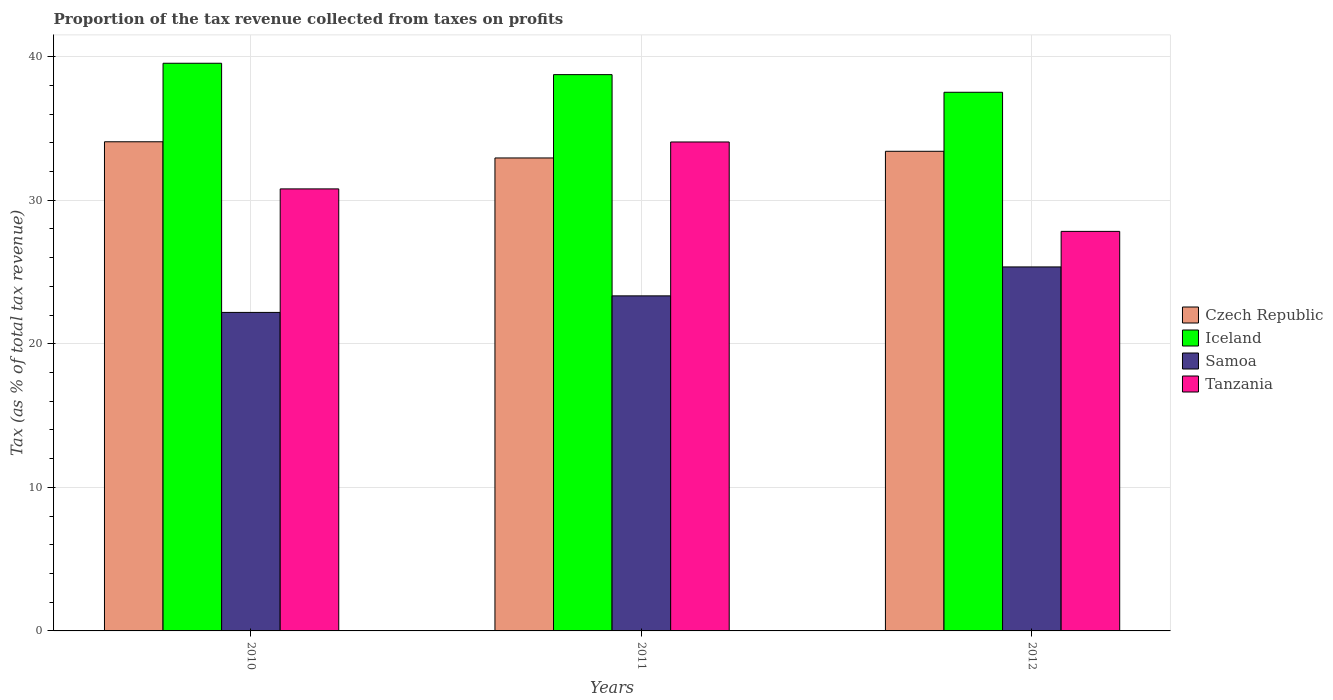How many different coloured bars are there?
Your response must be concise. 4. How many groups of bars are there?
Provide a short and direct response. 3. What is the proportion of the tax revenue collected in Czech Republic in 2011?
Provide a short and direct response. 32.94. Across all years, what is the maximum proportion of the tax revenue collected in Iceland?
Your answer should be very brief. 39.53. Across all years, what is the minimum proportion of the tax revenue collected in Czech Republic?
Ensure brevity in your answer.  32.94. In which year was the proportion of the tax revenue collected in Samoa maximum?
Give a very brief answer. 2012. In which year was the proportion of the tax revenue collected in Czech Republic minimum?
Your answer should be compact. 2011. What is the total proportion of the tax revenue collected in Tanzania in the graph?
Provide a succinct answer. 92.66. What is the difference between the proportion of the tax revenue collected in Samoa in 2010 and that in 2011?
Provide a succinct answer. -1.15. What is the difference between the proportion of the tax revenue collected in Iceland in 2010 and the proportion of the tax revenue collected in Tanzania in 2012?
Provide a short and direct response. 11.71. What is the average proportion of the tax revenue collected in Tanzania per year?
Keep it short and to the point. 30.89. In the year 2011, what is the difference between the proportion of the tax revenue collected in Tanzania and proportion of the tax revenue collected in Iceland?
Ensure brevity in your answer.  -4.69. In how many years, is the proportion of the tax revenue collected in Tanzania greater than 16 %?
Your answer should be very brief. 3. What is the ratio of the proportion of the tax revenue collected in Czech Republic in 2010 to that in 2012?
Keep it short and to the point. 1.02. Is the proportion of the tax revenue collected in Samoa in 2010 less than that in 2011?
Make the answer very short. Yes. What is the difference between the highest and the second highest proportion of the tax revenue collected in Czech Republic?
Your response must be concise. 0.66. What is the difference between the highest and the lowest proportion of the tax revenue collected in Czech Republic?
Your response must be concise. 1.13. What does the 3rd bar from the left in 2012 represents?
Provide a succinct answer. Samoa. What does the 4th bar from the right in 2011 represents?
Your answer should be very brief. Czech Republic. How many bars are there?
Your response must be concise. 12. What is the difference between two consecutive major ticks on the Y-axis?
Make the answer very short. 10. Does the graph contain any zero values?
Your answer should be compact. No. How many legend labels are there?
Ensure brevity in your answer.  4. What is the title of the graph?
Your response must be concise. Proportion of the tax revenue collected from taxes on profits. What is the label or title of the Y-axis?
Provide a succinct answer. Tax (as % of total tax revenue). What is the Tax (as % of total tax revenue) in Czech Republic in 2010?
Your answer should be compact. 34.07. What is the Tax (as % of total tax revenue) of Iceland in 2010?
Provide a succinct answer. 39.53. What is the Tax (as % of total tax revenue) of Samoa in 2010?
Ensure brevity in your answer.  22.18. What is the Tax (as % of total tax revenue) of Tanzania in 2010?
Keep it short and to the point. 30.78. What is the Tax (as % of total tax revenue) of Czech Republic in 2011?
Ensure brevity in your answer.  32.94. What is the Tax (as % of total tax revenue) of Iceland in 2011?
Ensure brevity in your answer.  38.74. What is the Tax (as % of total tax revenue) in Samoa in 2011?
Give a very brief answer. 23.33. What is the Tax (as % of total tax revenue) of Tanzania in 2011?
Your answer should be compact. 34.05. What is the Tax (as % of total tax revenue) of Czech Republic in 2012?
Offer a very short reply. 33.4. What is the Tax (as % of total tax revenue) in Iceland in 2012?
Make the answer very short. 37.51. What is the Tax (as % of total tax revenue) in Samoa in 2012?
Provide a succinct answer. 25.35. What is the Tax (as % of total tax revenue) in Tanzania in 2012?
Your answer should be very brief. 27.83. Across all years, what is the maximum Tax (as % of total tax revenue) of Czech Republic?
Your response must be concise. 34.07. Across all years, what is the maximum Tax (as % of total tax revenue) of Iceland?
Give a very brief answer. 39.53. Across all years, what is the maximum Tax (as % of total tax revenue) of Samoa?
Offer a very short reply. 25.35. Across all years, what is the maximum Tax (as % of total tax revenue) in Tanzania?
Your answer should be very brief. 34.05. Across all years, what is the minimum Tax (as % of total tax revenue) in Czech Republic?
Ensure brevity in your answer.  32.94. Across all years, what is the minimum Tax (as % of total tax revenue) in Iceland?
Offer a terse response. 37.51. Across all years, what is the minimum Tax (as % of total tax revenue) of Samoa?
Your answer should be very brief. 22.18. Across all years, what is the minimum Tax (as % of total tax revenue) in Tanzania?
Provide a short and direct response. 27.83. What is the total Tax (as % of total tax revenue) of Czech Republic in the graph?
Make the answer very short. 100.41. What is the total Tax (as % of total tax revenue) of Iceland in the graph?
Provide a short and direct response. 115.79. What is the total Tax (as % of total tax revenue) of Samoa in the graph?
Ensure brevity in your answer.  70.87. What is the total Tax (as % of total tax revenue) of Tanzania in the graph?
Ensure brevity in your answer.  92.66. What is the difference between the Tax (as % of total tax revenue) in Czech Republic in 2010 and that in 2011?
Make the answer very short. 1.13. What is the difference between the Tax (as % of total tax revenue) of Iceland in 2010 and that in 2011?
Provide a short and direct response. 0.79. What is the difference between the Tax (as % of total tax revenue) of Samoa in 2010 and that in 2011?
Make the answer very short. -1.15. What is the difference between the Tax (as % of total tax revenue) of Tanzania in 2010 and that in 2011?
Make the answer very short. -3.27. What is the difference between the Tax (as % of total tax revenue) of Czech Republic in 2010 and that in 2012?
Your answer should be very brief. 0.66. What is the difference between the Tax (as % of total tax revenue) in Iceland in 2010 and that in 2012?
Give a very brief answer. 2.02. What is the difference between the Tax (as % of total tax revenue) of Samoa in 2010 and that in 2012?
Ensure brevity in your answer.  -3.17. What is the difference between the Tax (as % of total tax revenue) of Tanzania in 2010 and that in 2012?
Offer a terse response. 2.96. What is the difference between the Tax (as % of total tax revenue) of Czech Republic in 2011 and that in 2012?
Your answer should be very brief. -0.46. What is the difference between the Tax (as % of total tax revenue) in Iceland in 2011 and that in 2012?
Give a very brief answer. 1.23. What is the difference between the Tax (as % of total tax revenue) in Samoa in 2011 and that in 2012?
Keep it short and to the point. -2.01. What is the difference between the Tax (as % of total tax revenue) in Tanzania in 2011 and that in 2012?
Ensure brevity in your answer.  6.23. What is the difference between the Tax (as % of total tax revenue) in Czech Republic in 2010 and the Tax (as % of total tax revenue) in Iceland in 2011?
Give a very brief answer. -4.68. What is the difference between the Tax (as % of total tax revenue) of Czech Republic in 2010 and the Tax (as % of total tax revenue) of Samoa in 2011?
Provide a succinct answer. 10.73. What is the difference between the Tax (as % of total tax revenue) in Czech Republic in 2010 and the Tax (as % of total tax revenue) in Tanzania in 2011?
Make the answer very short. 0.01. What is the difference between the Tax (as % of total tax revenue) in Iceland in 2010 and the Tax (as % of total tax revenue) in Samoa in 2011?
Your answer should be very brief. 16.2. What is the difference between the Tax (as % of total tax revenue) in Iceland in 2010 and the Tax (as % of total tax revenue) in Tanzania in 2011?
Your answer should be very brief. 5.48. What is the difference between the Tax (as % of total tax revenue) in Samoa in 2010 and the Tax (as % of total tax revenue) in Tanzania in 2011?
Ensure brevity in your answer.  -11.87. What is the difference between the Tax (as % of total tax revenue) of Czech Republic in 2010 and the Tax (as % of total tax revenue) of Iceland in 2012?
Your answer should be very brief. -3.45. What is the difference between the Tax (as % of total tax revenue) in Czech Republic in 2010 and the Tax (as % of total tax revenue) in Samoa in 2012?
Your response must be concise. 8.72. What is the difference between the Tax (as % of total tax revenue) in Czech Republic in 2010 and the Tax (as % of total tax revenue) in Tanzania in 2012?
Provide a short and direct response. 6.24. What is the difference between the Tax (as % of total tax revenue) of Iceland in 2010 and the Tax (as % of total tax revenue) of Samoa in 2012?
Offer a terse response. 14.18. What is the difference between the Tax (as % of total tax revenue) in Iceland in 2010 and the Tax (as % of total tax revenue) in Tanzania in 2012?
Make the answer very short. 11.71. What is the difference between the Tax (as % of total tax revenue) of Samoa in 2010 and the Tax (as % of total tax revenue) of Tanzania in 2012?
Ensure brevity in your answer.  -5.64. What is the difference between the Tax (as % of total tax revenue) in Czech Republic in 2011 and the Tax (as % of total tax revenue) in Iceland in 2012?
Give a very brief answer. -4.58. What is the difference between the Tax (as % of total tax revenue) of Czech Republic in 2011 and the Tax (as % of total tax revenue) of Samoa in 2012?
Keep it short and to the point. 7.59. What is the difference between the Tax (as % of total tax revenue) of Czech Republic in 2011 and the Tax (as % of total tax revenue) of Tanzania in 2012?
Give a very brief answer. 5.11. What is the difference between the Tax (as % of total tax revenue) in Iceland in 2011 and the Tax (as % of total tax revenue) in Samoa in 2012?
Your answer should be compact. 13.39. What is the difference between the Tax (as % of total tax revenue) of Iceland in 2011 and the Tax (as % of total tax revenue) of Tanzania in 2012?
Make the answer very short. 10.92. What is the difference between the Tax (as % of total tax revenue) in Samoa in 2011 and the Tax (as % of total tax revenue) in Tanzania in 2012?
Your response must be concise. -4.49. What is the average Tax (as % of total tax revenue) in Czech Republic per year?
Provide a short and direct response. 33.47. What is the average Tax (as % of total tax revenue) in Iceland per year?
Keep it short and to the point. 38.6. What is the average Tax (as % of total tax revenue) in Samoa per year?
Offer a terse response. 23.62. What is the average Tax (as % of total tax revenue) of Tanzania per year?
Your answer should be very brief. 30.89. In the year 2010, what is the difference between the Tax (as % of total tax revenue) in Czech Republic and Tax (as % of total tax revenue) in Iceland?
Offer a terse response. -5.47. In the year 2010, what is the difference between the Tax (as % of total tax revenue) in Czech Republic and Tax (as % of total tax revenue) in Samoa?
Offer a very short reply. 11.88. In the year 2010, what is the difference between the Tax (as % of total tax revenue) of Czech Republic and Tax (as % of total tax revenue) of Tanzania?
Keep it short and to the point. 3.28. In the year 2010, what is the difference between the Tax (as % of total tax revenue) in Iceland and Tax (as % of total tax revenue) in Samoa?
Offer a terse response. 17.35. In the year 2010, what is the difference between the Tax (as % of total tax revenue) in Iceland and Tax (as % of total tax revenue) in Tanzania?
Your answer should be compact. 8.75. In the year 2010, what is the difference between the Tax (as % of total tax revenue) in Samoa and Tax (as % of total tax revenue) in Tanzania?
Give a very brief answer. -8.6. In the year 2011, what is the difference between the Tax (as % of total tax revenue) in Czech Republic and Tax (as % of total tax revenue) in Iceland?
Your response must be concise. -5.8. In the year 2011, what is the difference between the Tax (as % of total tax revenue) of Czech Republic and Tax (as % of total tax revenue) of Samoa?
Provide a succinct answer. 9.6. In the year 2011, what is the difference between the Tax (as % of total tax revenue) of Czech Republic and Tax (as % of total tax revenue) of Tanzania?
Give a very brief answer. -1.11. In the year 2011, what is the difference between the Tax (as % of total tax revenue) in Iceland and Tax (as % of total tax revenue) in Samoa?
Your answer should be compact. 15.41. In the year 2011, what is the difference between the Tax (as % of total tax revenue) in Iceland and Tax (as % of total tax revenue) in Tanzania?
Your response must be concise. 4.69. In the year 2011, what is the difference between the Tax (as % of total tax revenue) of Samoa and Tax (as % of total tax revenue) of Tanzania?
Your answer should be compact. -10.72. In the year 2012, what is the difference between the Tax (as % of total tax revenue) of Czech Republic and Tax (as % of total tax revenue) of Iceland?
Offer a very short reply. -4.11. In the year 2012, what is the difference between the Tax (as % of total tax revenue) of Czech Republic and Tax (as % of total tax revenue) of Samoa?
Provide a succinct answer. 8.05. In the year 2012, what is the difference between the Tax (as % of total tax revenue) of Czech Republic and Tax (as % of total tax revenue) of Tanzania?
Offer a very short reply. 5.58. In the year 2012, what is the difference between the Tax (as % of total tax revenue) of Iceland and Tax (as % of total tax revenue) of Samoa?
Give a very brief answer. 12.16. In the year 2012, what is the difference between the Tax (as % of total tax revenue) of Iceland and Tax (as % of total tax revenue) of Tanzania?
Keep it short and to the point. 9.69. In the year 2012, what is the difference between the Tax (as % of total tax revenue) in Samoa and Tax (as % of total tax revenue) in Tanzania?
Offer a terse response. -2.48. What is the ratio of the Tax (as % of total tax revenue) in Czech Republic in 2010 to that in 2011?
Offer a very short reply. 1.03. What is the ratio of the Tax (as % of total tax revenue) of Iceland in 2010 to that in 2011?
Give a very brief answer. 1.02. What is the ratio of the Tax (as % of total tax revenue) in Samoa in 2010 to that in 2011?
Make the answer very short. 0.95. What is the ratio of the Tax (as % of total tax revenue) in Tanzania in 2010 to that in 2011?
Provide a short and direct response. 0.9. What is the ratio of the Tax (as % of total tax revenue) of Czech Republic in 2010 to that in 2012?
Offer a very short reply. 1.02. What is the ratio of the Tax (as % of total tax revenue) of Iceland in 2010 to that in 2012?
Provide a succinct answer. 1.05. What is the ratio of the Tax (as % of total tax revenue) in Samoa in 2010 to that in 2012?
Your response must be concise. 0.88. What is the ratio of the Tax (as % of total tax revenue) in Tanzania in 2010 to that in 2012?
Your answer should be very brief. 1.11. What is the ratio of the Tax (as % of total tax revenue) in Czech Republic in 2011 to that in 2012?
Offer a very short reply. 0.99. What is the ratio of the Tax (as % of total tax revenue) of Iceland in 2011 to that in 2012?
Make the answer very short. 1.03. What is the ratio of the Tax (as % of total tax revenue) in Samoa in 2011 to that in 2012?
Your answer should be very brief. 0.92. What is the ratio of the Tax (as % of total tax revenue) in Tanzania in 2011 to that in 2012?
Provide a succinct answer. 1.22. What is the difference between the highest and the second highest Tax (as % of total tax revenue) in Czech Republic?
Ensure brevity in your answer.  0.66. What is the difference between the highest and the second highest Tax (as % of total tax revenue) in Iceland?
Make the answer very short. 0.79. What is the difference between the highest and the second highest Tax (as % of total tax revenue) in Samoa?
Give a very brief answer. 2.01. What is the difference between the highest and the second highest Tax (as % of total tax revenue) in Tanzania?
Your answer should be very brief. 3.27. What is the difference between the highest and the lowest Tax (as % of total tax revenue) in Czech Republic?
Make the answer very short. 1.13. What is the difference between the highest and the lowest Tax (as % of total tax revenue) of Iceland?
Your response must be concise. 2.02. What is the difference between the highest and the lowest Tax (as % of total tax revenue) in Samoa?
Ensure brevity in your answer.  3.17. What is the difference between the highest and the lowest Tax (as % of total tax revenue) in Tanzania?
Provide a succinct answer. 6.23. 